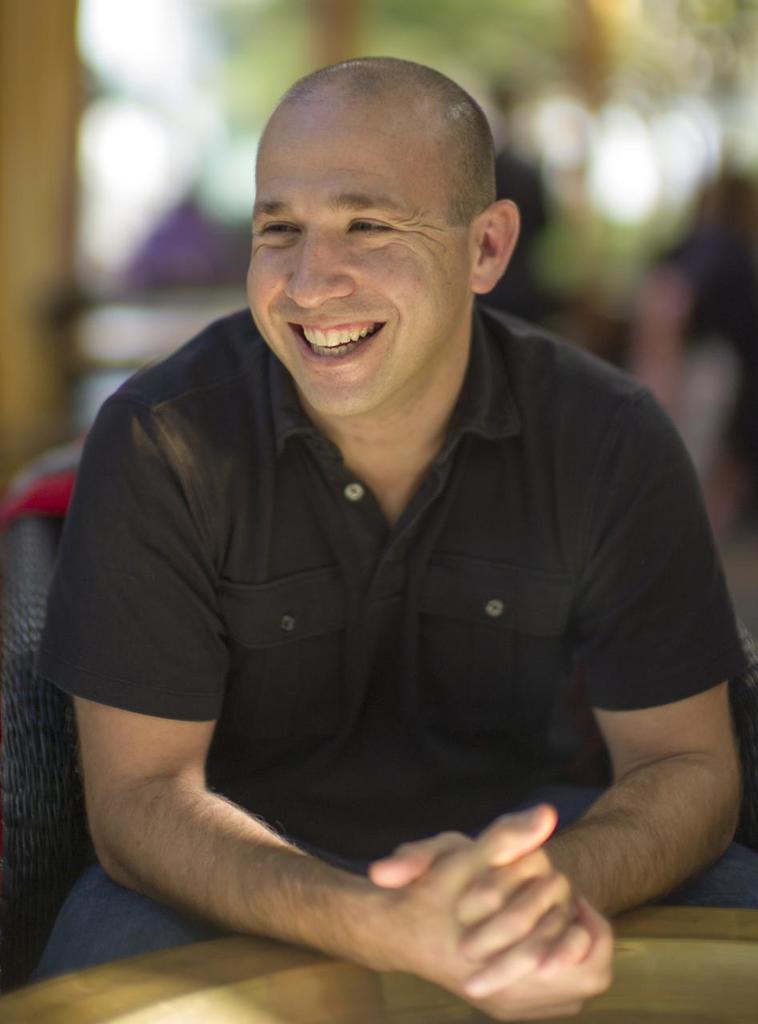In one or two sentences, can you explain what this image depicts? In this picture we can see a person sitting on a chair and smiling. There is a wooden object. Background is blurry. 